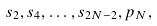Convert formula to latex. <formula><loc_0><loc_0><loc_500><loc_500>s _ { 2 } , s _ { 4 } , \dots , s _ { 2 N - 2 } , p _ { N } ,</formula> 